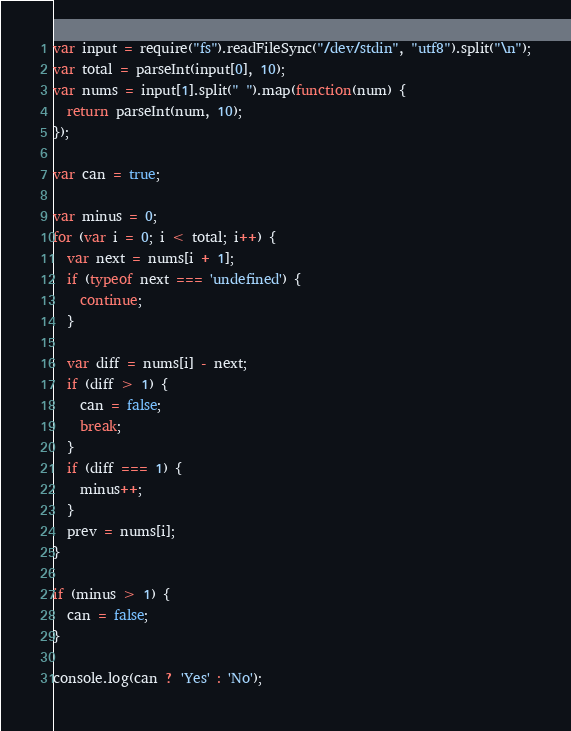<code> <loc_0><loc_0><loc_500><loc_500><_JavaScript_>var input = require("fs").readFileSync("/dev/stdin", "utf8").split("\n");
var total = parseInt(input[0], 10);
var nums = input[1].split(" ").map(function(num) {
  return parseInt(num, 10);
});

var can = true;

var minus = 0;
for (var i = 0; i < total; i++) {
  var next = nums[i + 1];
  if (typeof next === 'undefined') {
    continue;
  }

  var diff = nums[i] - next;
  if (diff > 1) {
    can = false;
    break;
  }
  if (diff === 1) {
    minus++;
  }
  prev = nums[i];
}

if (minus > 1) {
  can = false;
}

console.log(can ? 'Yes' : 'No');
</code> 